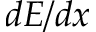<formula> <loc_0><loc_0><loc_500><loc_500>d E / d x</formula> 